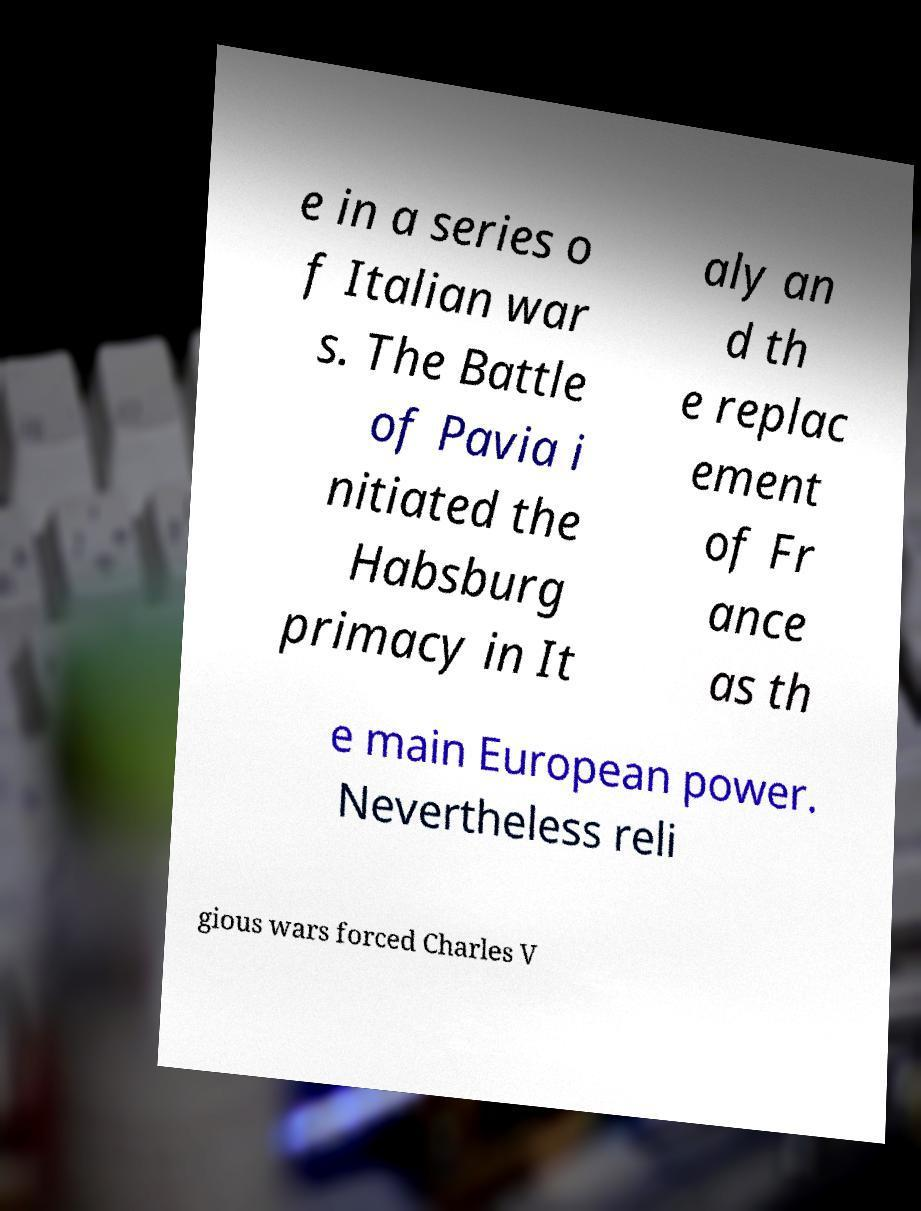Please read and relay the text visible in this image. What does it say? e in a series o f Italian war s. The Battle of Pavia i nitiated the Habsburg primacy in It aly an d th e replac ement of Fr ance as th e main European power. Nevertheless reli gious wars forced Charles V 